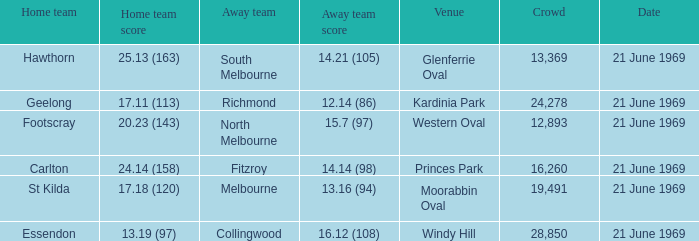What is Essendon's home team that has an away crowd size larger than 19,491? Collingwood. 